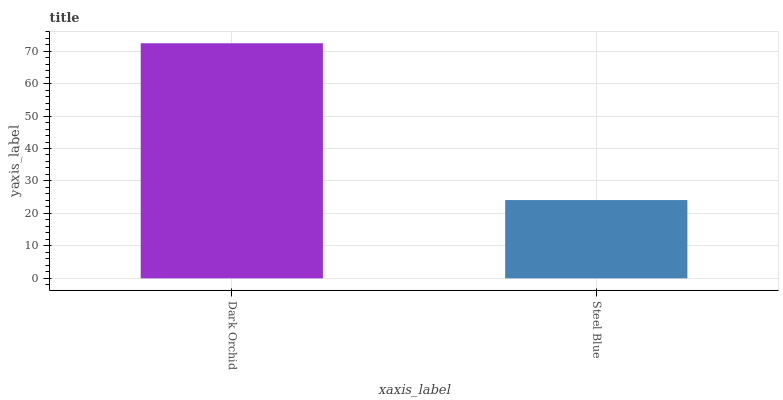Is Steel Blue the maximum?
Answer yes or no. No. Is Dark Orchid greater than Steel Blue?
Answer yes or no. Yes. Is Steel Blue less than Dark Orchid?
Answer yes or no. Yes. Is Steel Blue greater than Dark Orchid?
Answer yes or no. No. Is Dark Orchid less than Steel Blue?
Answer yes or no. No. Is Dark Orchid the high median?
Answer yes or no. Yes. Is Steel Blue the low median?
Answer yes or no. Yes. Is Steel Blue the high median?
Answer yes or no. No. Is Dark Orchid the low median?
Answer yes or no. No. 